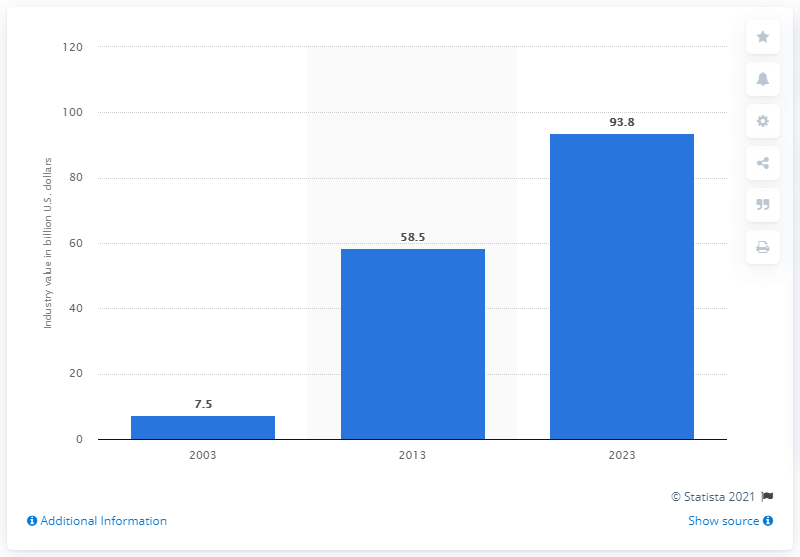Identify some key points in this picture. The forecast for the global wind power equipment manufacturing market in 2023 is... The estimated value of the global wind power equipment manufacturing market is projected to be 93.8 billion dollars by 2023. 